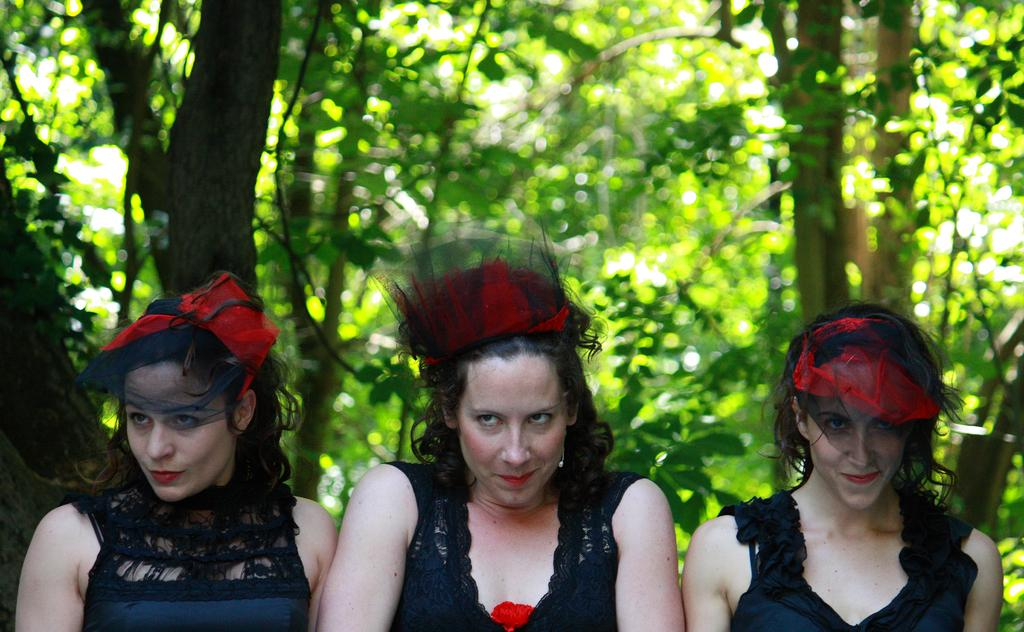How many women are present in the image? There are three women in the image. What are the women doing in the image? The women are smiling in the image. What are the women wearing in the image? The women are wearing black dresses in the image. What can be seen in the background of the image? There are trees in the background of the image. What type of dirt can be seen on the women's shoes in the image? There is no dirt visible on the women's shoes in the image, as their feet and shoes are not shown. Can you tell me how many monkeys are sitting on the women's shoulders in the image? There are no monkeys present in the image; only the three women are visible. 